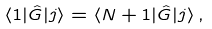<formula> <loc_0><loc_0><loc_500><loc_500>\langle 1 | \hat { G } | j \rangle = \langle N + 1 | \hat { G } | j \rangle \, ,</formula> 